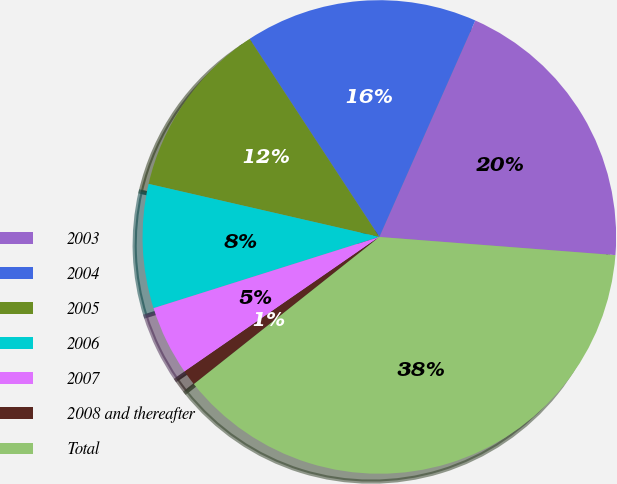Convert chart to OTSL. <chart><loc_0><loc_0><loc_500><loc_500><pie_chart><fcel>2003<fcel>2004<fcel>2005<fcel>2006<fcel>2007<fcel>2008 and thereafter<fcel>Total<nl><fcel>19.58%<fcel>15.87%<fcel>12.17%<fcel>8.46%<fcel>4.76%<fcel>1.05%<fcel>38.1%<nl></chart> 